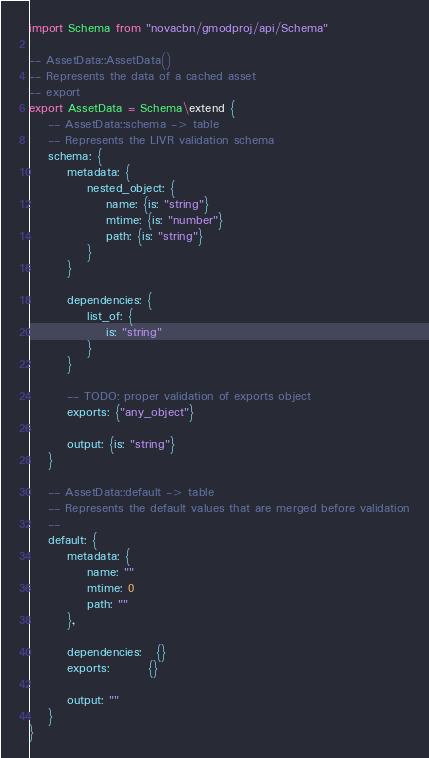Convert code to text. <code><loc_0><loc_0><loc_500><loc_500><_MoonScript_>import Schema from "novacbn/gmodproj/api/Schema"

-- AssetData::AssetData()
-- Represents the data of a cached asset
-- export
export AssetData = Schema\extend {
    -- AssetData::schema -> table
    -- Represents the LIVR validation schema
    schema: {
        metadata: {
            nested_object: {
                name: {is: "string"}
                mtime: {is: "number"}
                path: {is: "string"}
            }
        }

        dependencies: {
            list_of: {
                is: "string"
            }
        }

        -- TODO: proper validation of exports object
        exports: {"any_object"}

        output: {is: "string"}
    }

    -- AssetData::default -> table
    -- Represents the default values that are merged before validation
    --
    default: {
        metadata: {
            name: ""
            mtime: 0
            path: ""
        },

        dependencies:   {}
        exports:        {}

        output: ""
    }
}</code> 